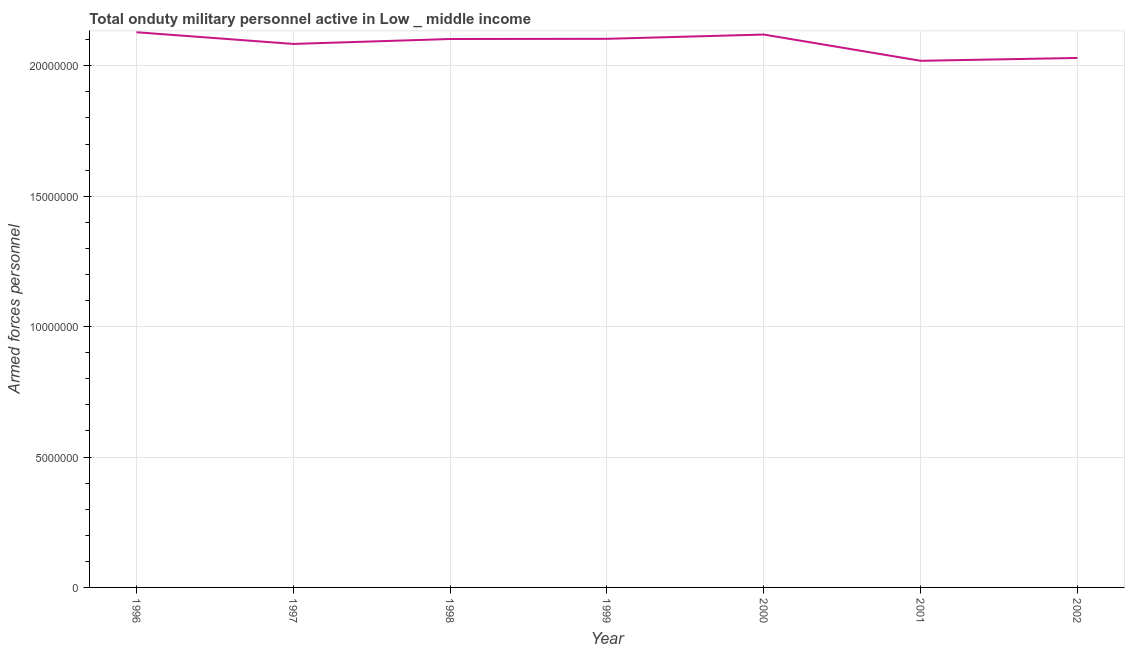What is the number of armed forces personnel in 1997?
Offer a terse response. 2.08e+07. Across all years, what is the maximum number of armed forces personnel?
Provide a short and direct response. 2.13e+07. Across all years, what is the minimum number of armed forces personnel?
Provide a succinct answer. 2.02e+07. In which year was the number of armed forces personnel minimum?
Your answer should be very brief. 2001. What is the sum of the number of armed forces personnel?
Your response must be concise. 1.46e+08. What is the difference between the number of armed forces personnel in 1998 and 2002?
Your response must be concise. 7.27e+05. What is the average number of armed forces personnel per year?
Offer a terse response. 2.08e+07. What is the median number of armed forces personnel?
Your response must be concise. 2.10e+07. In how many years, is the number of armed forces personnel greater than 2000000 ?
Offer a very short reply. 7. What is the ratio of the number of armed forces personnel in 1997 to that in 1998?
Your response must be concise. 0.99. Is the difference between the number of armed forces personnel in 1997 and 2001 greater than the difference between any two years?
Give a very brief answer. No. What is the difference between the highest and the second highest number of armed forces personnel?
Provide a succinct answer. 8.80e+04. What is the difference between the highest and the lowest number of armed forces personnel?
Make the answer very short. 1.09e+06. Does the number of armed forces personnel monotonically increase over the years?
Make the answer very short. No. How many lines are there?
Ensure brevity in your answer.  1. How many years are there in the graph?
Provide a succinct answer. 7. What is the title of the graph?
Make the answer very short. Total onduty military personnel active in Low _ middle income. What is the label or title of the Y-axis?
Your answer should be very brief. Armed forces personnel. What is the Armed forces personnel in 1996?
Your response must be concise. 2.13e+07. What is the Armed forces personnel in 1997?
Offer a very short reply. 2.08e+07. What is the Armed forces personnel in 1998?
Provide a succinct answer. 2.10e+07. What is the Armed forces personnel of 1999?
Give a very brief answer. 2.10e+07. What is the Armed forces personnel of 2000?
Offer a terse response. 2.12e+07. What is the Armed forces personnel in 2001?
Keep it short and to the point. 2.02e+07. What is the Armed forces personnel in 2002?
Make the answer very short. 2.03e+07. What is the difference between the Armed forces personnel in 1996 and 1997?
Ensure brevity in your answer.  4.48e+05. What is the difference between the Armed forces personnel in 1996 and 1998?
Ensure brevity in your answer.  2.59e+05. What is the difference between the Armed forces personnel in 1996 and 1999?
Provide a short and direct response. 2.52e+05. What is the difference between the Armed forces personnel in 1996 and 2000?
Keep it short and to the point. 8.80e+04. What is the difference between the Armed forces personnel in 1996 and 2001?
Your response must be concise. 1.09e+06. What is the difference between the Armed forces personnel in 1996 and 2002?
Your response must be concise. 9.85e+05. What is the difference between the Armed forces personnel in 1997 and 1998?
Ensure brevity in your answer.  -1.89e+05. What is the difference between the Armed forces personnel in 1997 and 1999?
Make the answer very short. -1.96e+05. What is the difference between the Armed forces personnel in 1997 and 2000?
Your answer should be very brief. -3.60e+05. What is the difference between the Armed forces personnel in 1997 and 2001?
Your answer should be very brief. 6.46e+05. What is the difference between the Armed forces personnel in 1997 and 2002?
Make the answer very short. 5.38e+05. What is the difference between the Armed forces personnel in 1998 and 1999?
Provide a succinct answer. -7180. What is the difference between the Armed forces personnel in 1998 and 2000?
Make the answer very short. -1.71e+05. What is the difference between the Armed forces personnel in 1998 and 2001?
Provide a succinct answer. 8.35e+05. What is the difference between the Armed forces personnel in 1998 and 2002?
Make the answer very short. 7.27e+05. What is the difference between the Armed forces personnel in 1999 and 2000?
Offer a terse response. -1.64e+05. What is the difference between the Armed forces personnel in 1999 and 2001?
Provide a succinct answer. 8.43e+05. What is the difference between the Armed forces personnel in 1999 and 2002?
Give a very brief answer. 7.34e+05. What is the difference between the Armed forces personnel in 2000 and 2001?
Offer a very short reply. 1.01e+06. What is the difference between the Armed forces personnel in 2000 and 2002?
Ensure brevity in your answer.  8.97e+05. What is the difference between the Armed forces personnel in 2001 and 2002?
Give a very brief answer. -1.09e+05. What is the ratio of the Armed forces personnel in 1996 to that in 1998?
Make the answer very short. 1.01. What is the ratio of the Armed forces personnel in 1996 to that in 1999?
Provide a succinct answer. 1.01. What is the ratio of the Armed forces personnel in 1996 to that in 2000?
Give a very brief answer. 1. What is the ratio of the Armed forces personnel in 1996 to that in 2001?
Offer a very short reply. 1.05. What is the ratio of the Armed forces personnel in 1996 to that in 2002?
Offer a terse response. 1.05. What is the ratio of the Armed forces personnel in 1997 to that in 1998?
Keep it short and to the point. 0.99. What is the ratio of the Armed forces personnel in 1997 to that in 1999?
Your answer should be compact. 0.99. What is the ratio of the Armed forces personnel in 1997 to that in 2001?
Ensure brevity in your answer.  1.03. What is the ratio of the Armed forces personnel in 1998 to that in 1999?
Keep it short and to the point. 1. What is the ratio of the Armed forces personnel in 1998 to that in 2000?
Your answer should be very brief. 0.99. What is the ratio of the Armed forces personnel in 1998 to that in 2001?
Your answer should be compact. 1.04. What is the ratio of the Armed forces personnel in 1998 to that in 2002?
Keep it short and to the point. 1.04. What is the ratio of the Armed forces personnel in 1999 to that in 2001?
Ensure brevity in your answer.  1.04. What is the ratio of the Armed forces personnel in 1999 to that in 2002?
Provide a succinct answer. 1.04. What is the ratio of the Armed forces personnel in 2000 to that in 2002?
Keep it short and to the point. 1.04. What is the ratio of the Armed forces personnel in 2001 to that in 2002?
Provide a succinct answer. 0.99. 